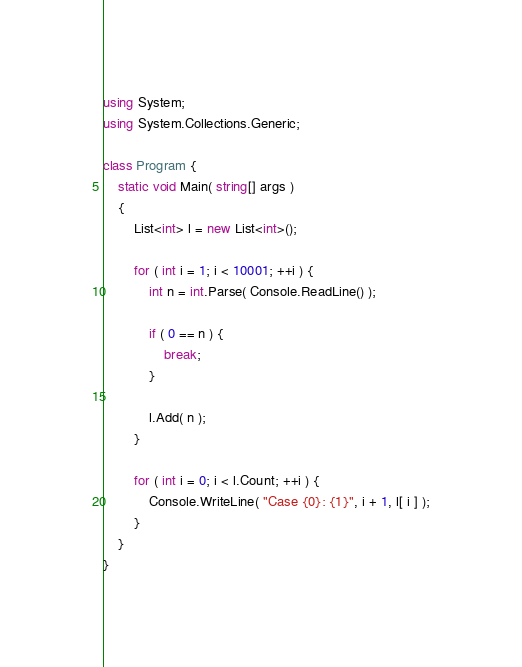<code> <loc_0><loc_0><loc_500><loc_500><_C#_>using System;
using System.Collections.Generic;

class Program {
    static void Main( string[] args )
    {
        List<int> l = new List<int>();

        for ( int i = 1; i < 10001; ++i ) {
            int n = int.Parse( Console.ReadLine() );

            if ( 0 == n ) {
                break;
            }

            l.Add( n );
        }

        for ( int i = 0; i < l.Count; ++i ) {
            Console.WriteLine( "Case {0}: {1}", i + 1, l[ i ] );
        }
    }
}</code> 